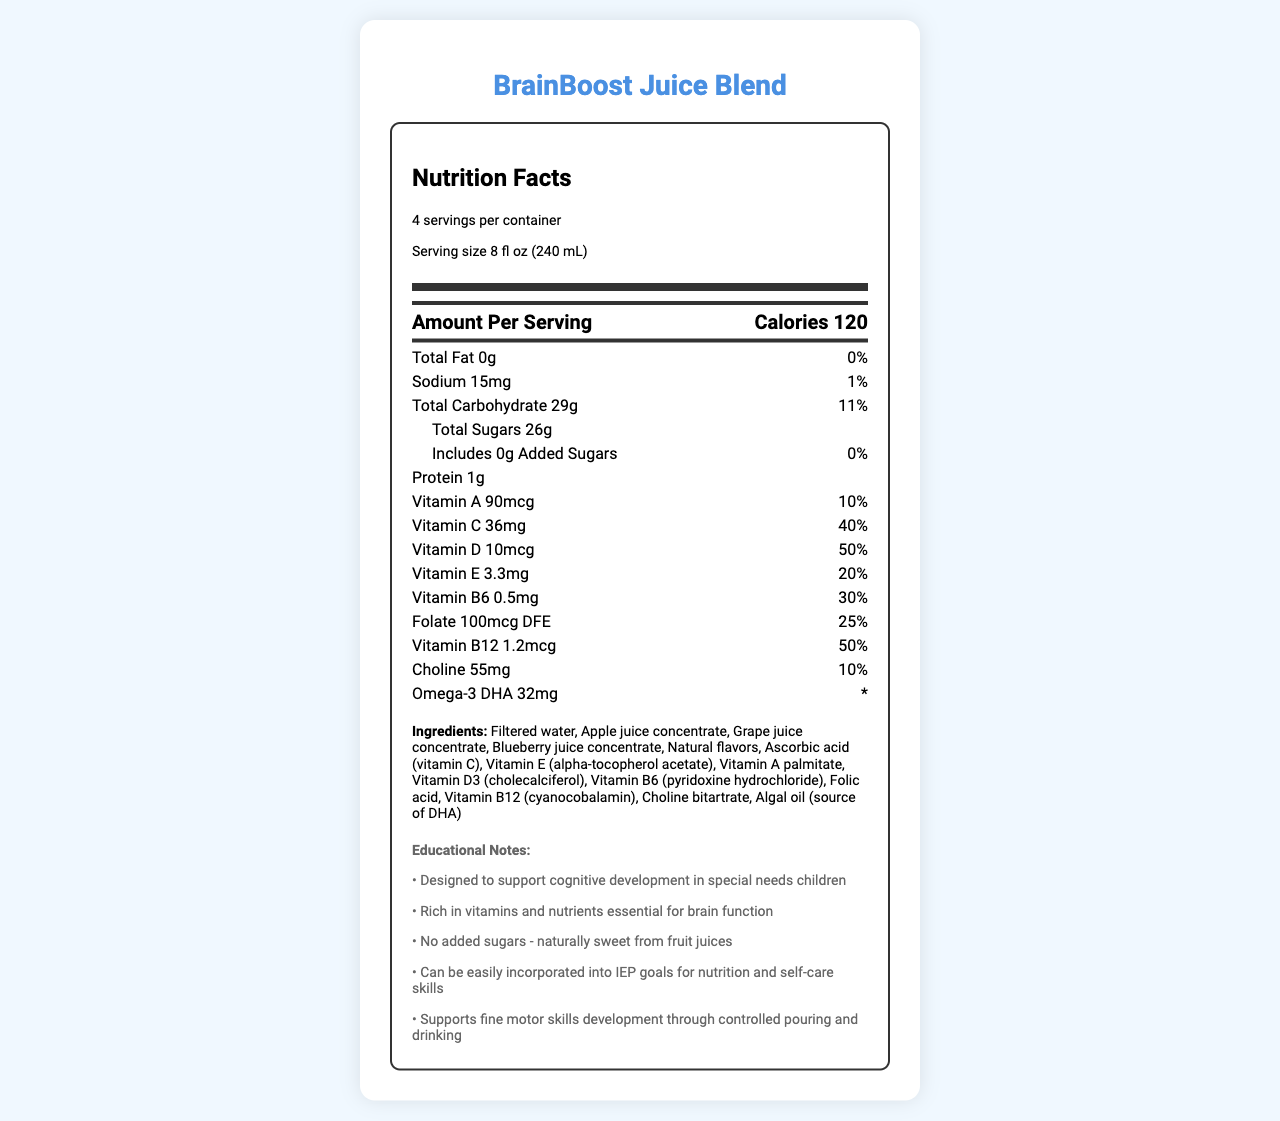what is the serving size for BrainBoost Juice Blend? The serving size is specified near the top of the nutrition facts label.
Answer: 8 fl oz (240 mL) How many calories are in one serving of BrainBoost Juice Blend? The calories per serving is listed under the "Amount Per Serving" section.
Answer: 120 How much Vitamin D is in one serving, and what is its daily value percentage? This information is found in the vitamins section, under "Vitamin D".
Answer: 10mcg, 50% How many servings are there per container of BrainBoost Juice Blend? The number of servings per container is listed at the top of the nutrition facts label.
Answer: 4 List the first three ingredients of BrainBoost Juice Blend. The ingredients are listed towards the bottom of the document in the ingredients section.
Answer: Filtered water, Apple juice concentrate, Grape juice concentrate What is the amount of Total Sugars in one serving? This is found under the "Total Carbohydrate" section listed as "Total Sugars".
Answer: 26g Does BrainBoost Juice Blend contain any allergens? The allergen information states "Contains: None".
Answer: No Which vitamin has the highest daily value percentage in BrainBoost Juice Blend? A. Vitamin A B. Vitamin C C. Vitamin D D. Vitamin B12 Vitamin D has a 50% daily value, the highest among the listed vitamins.
Answer: C. Vitamin D How much Omega-3 DHA is in one serving? A. 10mg B. 32mg C. 50mg D. 75mg The nutrient list shows that the Omega-3 DHA amount is 32mg.
Answer: B. 32mg Are there any added sugars in BrainBoost Juice Blend? The document specifies that the Total Sugars include 0g of Added Sugars.
Answer: No Can BrainBoost Juice Blend be used to support fine motor skills development? The educational notes mention that it supports fine motor skills development through controlled pouring and drinking.
Answer: Yes Explain the main idea of the document. The document provides a comprehensive overview of the nutritional content of BrainBoost Juice Blend, its ingredients, allergen information, and educational benefits, all aimed at supporting cognitive and physical development in special needs children.
Answer: BrainBoost Juice Blend is a vitamin-fortified juice designed to support cognitive development in special needs children. The nutrition facts show detailed information on the serving size, calories, nutrients, and vitamins included. It is rich in essential nutrients for brain function and does not contain added sugars. The educational notes highlight its benefits for incorporating therapy goals into the classroom, including supporting nutrition, self-care, and motor skills. What is the distribution channel for BrainBoost Juice Blend? The distribution information is listed at the bottom of the document.
Answer: Exclusively for schools and therapy centers Does the BrainBoost Juice Blend contain Vitamin K? The nutrition facts label does not list Vitamin K, so its presence or absence cannot be determined from the given information.
Answer: Not enough information 